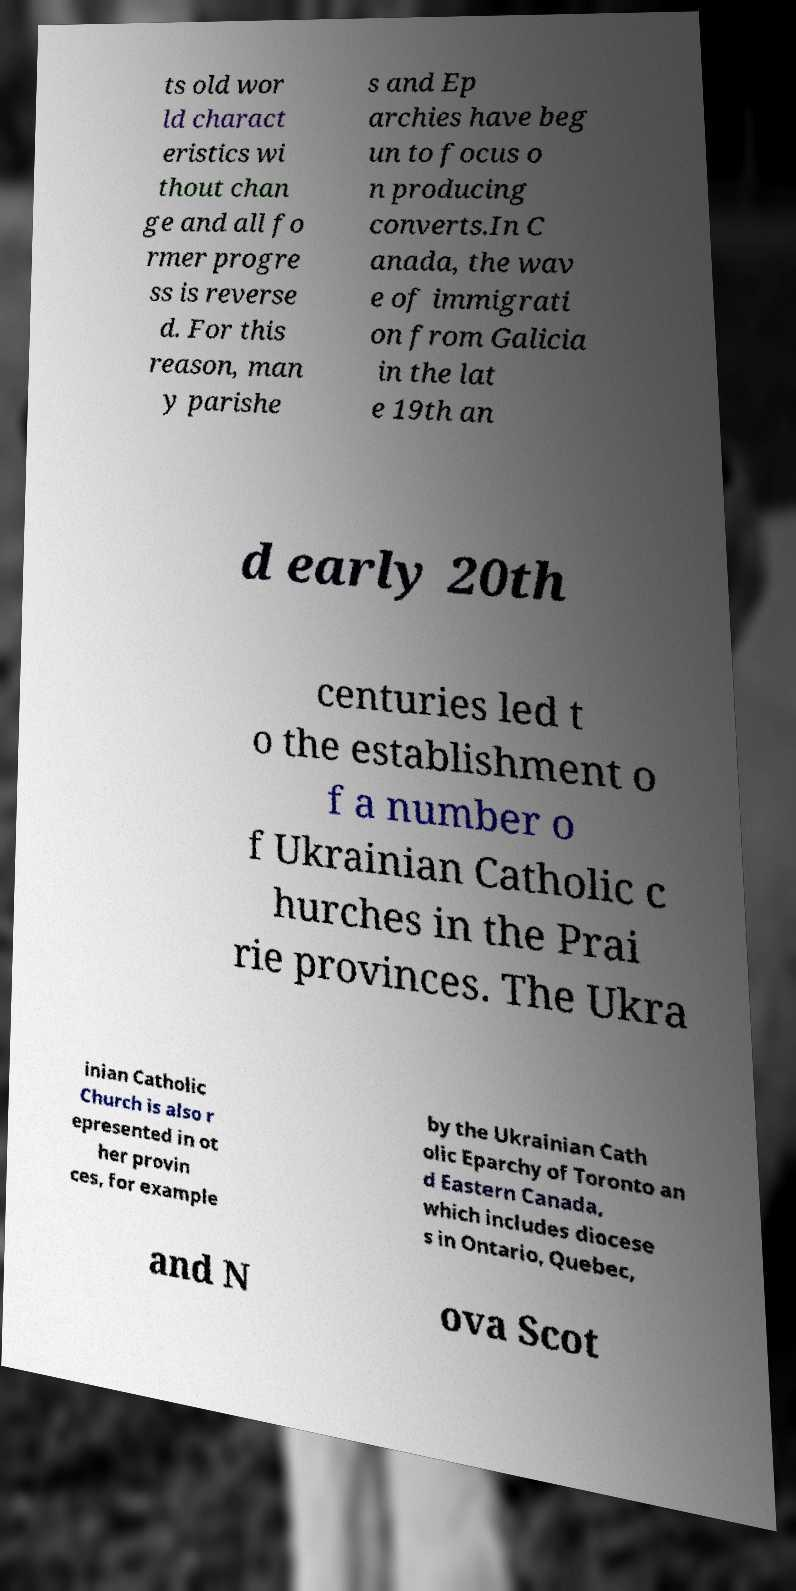For documentation purposes, I need the text within this image transcribed. Could you provide that? ts old wor ld charact eristics wi thout chan ge and all fo rmer progre ss is reverse d. For this reason, man y parishe s and Ep archies have beg un to focus o n producing converts.In C anada, the wav e of immigrati on from Galicia in the lat e 19th an d early 20th centuries led t o the establishment o f a number o f Ukrainian Catholic c hurches in the Prai rie provinces. The Ukra inian Catholic Church is also r epresented in ot her provin ces, for example by the Ukrainian Cath olic Eparchy of Toronto an d Eastern Canada, which includes diocese s in Ontario, Quebec, and N ova Scot 